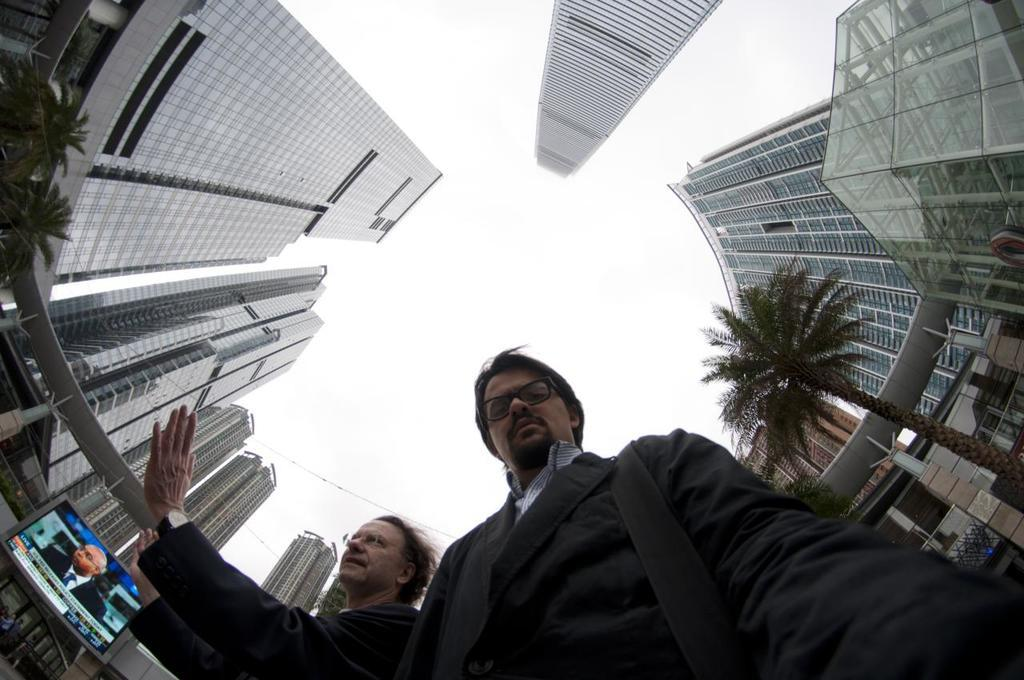How many people are present in the image? There are two people in the image. What type of natural elements can be seen in the image? There are trees in the image. What man-made structures are visible in the image? There are buildings in the image. What part of the natural environment is visible in the image? The sky is visible in the image. What type of waves can be seen in the image? There are no waves present in the image. What time of day is depicted in the image? The time of day cannot be determined from the image, as there is no specific indication of time. 